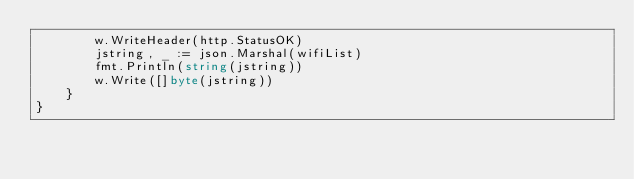Convert code to text. <code><loc_0><loc_0><loc_500><loc_500><_Go_>		w.WriteHeader(http.StatusOK)
		jstring, _ := json.Marshal(wifiList)
		fmt.Println(string(jstring))
		w.Write([]byte(jstring))
	}
}
</code> 